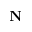<formula> <loc_0><loc_0><loc_500><loc_500>N</formula> 